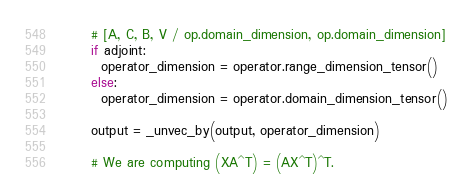Convert code to text. <code><loc_0><loc_0><loc_500><loc_500><_Python_>      # [A, C, B, V / op.domain_dimension, op.domain_dimension]
      if adjoint:
        operator_dimension = operator.range_dimension_tensor()
      else:
        operator_dimension = operator.domain_dimension_tensor()

      output = _unvec_by(output, operator_dimension)

      # We are computing (XA^T) = (AX^T)^T.</code> 